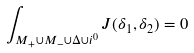Convert formula to latex. <formula><loc_0><loc_0><loc_500><loc_500>\int _ { M _ { + } \cup M _ { - } \cup \Delta \cup i ^ { 0 } } J ( \delta _ { 1 } , \delta _ { 2 } ) = 0</formula> 